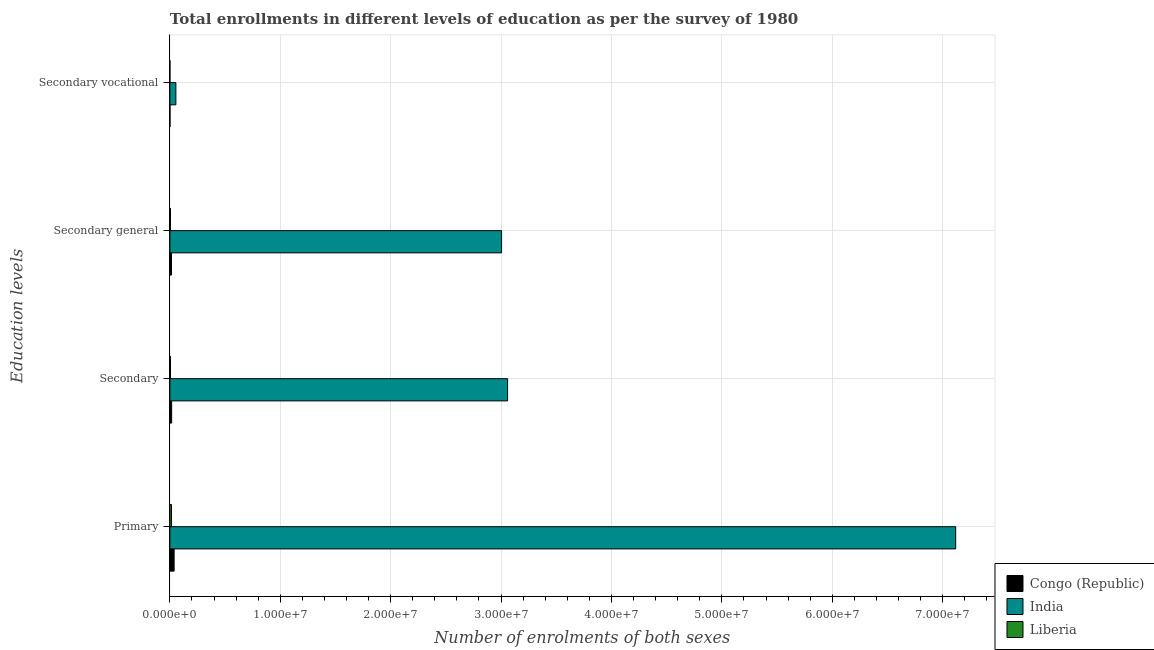How many groups of bars are there?
Your response must be concise. 4. How many bars are there on the 2nd tick from the bottom?
Keep it short and to the point. 3. What is the label of the 1st group of bars from the top?
Ensure brevity in your answer.  Secondary vocational. What is the number of enrolments in secondary general education in Congo (Republic)?
Keep it short and to the point. 1.49e+05. Across all countries, what is the maximum number of enrolments in secondary vocational education?
Provide a short and direct response. 5.44e+05. Across all countries, what is the minimum number of enrolments in primary education?
Your answer should be very brief. 1.47e+05. In which country was the number of enrolments in secondary vocational education maximum?
Your answer should be compact. India. In which country was the number of enrolments in secondary vocational education minimum?
Provide a succinct answer. Liberia. What is the total number of enrolments in secondary general education in the graph?
Offer a very short reply. 3.02e+07. What is the difference between the number of enrolments in secondary vocational education in Congo (Republic) and that in Liberia?
Provide a succinct answer. 7404. What is the difference between the number of enrolments in primary education in Congo (Republic) and the number of enrolments in secondary vocational education in Liberia?
Your response must be concise. 3.80e+05. What is the average number of enrolments in secondary education per country?
Your answer should be compact. 1.03e+07. What is the difference between the number of enrolments in secondary general education and number of enrolments in primary education in Liberia?
Your answer should be very brief. -9.56e+04. What is the ratio of the number of enrolments in secondary general education in India to that in Liberia?
Give a very brief answer. 581.59. What is the difference between the highest and the second highest number of enrolments in secondary general education?
Ensure brevity in your answer.  2.99e+07. What is the difference between the highest and the lowest number of enrolments in secondary general education?
Offer a terse response. 3.00e+07. In how many countries, is the number of enrolments in primary education greater than the average number of enrolments in primary education taken over all countries?
Ensure brevity in your answer.  1. Is it the case that in every country, the sum of the number of enrolments in secondary vocational education and number of enrolments in primary education is greater than the sum of number of enrolments in secondary general education and number of enrolments in secondary education?
Offer a very short reply. No. What does the 3rd bar from the top in Secondary represents?
Provide a short and direct response. Congo (Republic). What does the 3rd bar from the bottom in Secondary general represents?
Offer a very short reply. Liberia. Is it the case that in every country, the sum of the number of enrolments in primary education and number of enrolments in secondary education is greater than the number of enrolments in secondary general education?
Your response must be concise. Yes. How many bars are there?
Make the answer very short. 12. Are all the bars in the graph horizontal?
Provide a short and direct response. Yes. What is the difference between two consecutive major ticks on the X-axis?
Offer a terse response. 1.00e+07. What is the title of the graph?
Your answer should be very brief. Total enrollments in different levels of education as per the survey of 1980. Does "Mongolia" appear as one of the legend labels in the graph?
Your answer should be very brief. No. What is the label or title of the X-axis?
Offer a terse response. Number of enrolments of both sexes. What is the label or title of the Y-axis?
Offer a very short reply. Education levels. What is the Number of enrolments of both sexes of Congo (Republic) in Primary?
Provide a short and direct response. 3.83e+05. What is the Number of enrolments of both sexes in India in Primary?
Make the answer very short. 7.12e+07. What is the Number of enrolments of both sexes in Liberia in Primary?
Provide a succinct answer. 1.47e+05. What is the Number of enrolments of both sexes of Congo (Republic) in Secondary?
Offer a terse response. 1.59e+05. What is the Number of enrolments of both sexes in India in Secondary?
Keep it short and to the point. 3.06e+07. What is the Number of enrolments of both sexes in Liberia in Secondary?
Your answer should be very brief. 5.46e+04. What is the Number of enrolments of both sexes in Congo (Republic) in Secondary general?
Your answer should be compact. 1.49e+05. What is the Number of enrolments of both sexes in India in Secondary general?
Your answer should be very brief. 3.00e+07. What is the Number of enrolments of both sexes in Liberia in Secondary general?
Ensure brevity in your answer.  5.17e+04. What is the Number of enrolments of both sexes of Congo (Republic) in Secondary vocational?
Your answer should be compact. 1.04e+04. What is the Number of enrolments of both sexes of India in Secondary vocational?
Your answer should be very brief. 5.44e+05. What is the Number of enrolments of both sexes in Liberia in Secondary vocational?
Ensure brevity in your answer.  2957. Across all Education levels, what is the maximum Number of enrolments of both sexes in Congo (Republic)?
Your answer should be compact. 3.83e+05. Across all Education levels, what is the maximum Number of enrolments of both sexes in India?
Provide a succinct answer. 7.12e+07. Across all Education levels, what is the maximum Number of enrolments of both sexes in Liberia?
Your answer should be very brief. 1.47e+05. Across all Education levels, what is the minimum Number of enrolments of both sexes in Congo (Republic)?
Your answer should be compact. 1.04e+04. Across all Education levels, what is the minimum Number of enrolments of both sexes in India?
Your answer should be very brief. 5.44e+05. Across all Education levels, what is the minimum Number of enrolments of both sexes of Liberia?
Ensure brevity in your answer.  2957. What is the total Number of enrolments of both sexes of Congo (Republic) in the graph?
Give a very brief answer. 7.01e+05. What is the total Number of enrolments of both sexes of India in the graph?
Your answer should be compact. 1.32e+08. What is the total Number of enrolments of both sexes of Liberia in the graph?
Provide a succinct answer. 2.56e+05. What is the difference between the Number of enrolments of both sexes in Congo (Republic) in Primary and that in Secondary?
Provide a short and direct response. 2.24e+05. What is the difference between the Number of enrolments of both sexes in India in Primary and that in Secondary?
Provide a short and direct response. 4.06e+07. What is the difference between the Number of enrolments of both sexes in Liberia in Primary and that in Secondary?
Make the answer very short. 9.26e+04. What is the difference between the Number of enrolments of both sexes of Congo (Republic) in Primary and that in Secondary general?
Offer a terse response. 2.34e+05. What is the difference between the Number of enrolments of both sexes of India in Primary and that in Secondary general?
Offer a very short reply. 4.11e+07. What is the difference between the Number of enrolments of both sexes of Liberia in Primary and that in Secondary general?
Ensure brevity in your answer.  9.56e+04. What is the difference between the Number of enrolments of both sexes in Congo (Republic) in Primary and that in Secondary vocational?
Offer a terse response. 3.73e+05. What is the difference between the Number of enrolments of both sexes in India in Primary and that in Secondary vocational?
Offer a very short reply. 7.06e+07. What is the difference between the Number of enrolments of both sexes in Liberia in Primary and that in Secondary vocational?
Make the answer very short. 1.44e+05. What is the difference between the Number of enrolments of both sexes in Congo (Republic) in Secondary and that in Secondary general?
Keep it short and to the point. 1.04e+04. What is the difference between the Number of enrolments of both sexes in India in Secondary and that in Secondary general?
Ensure brevity in your answer.  5.44e+05. What is the difference between the Number of enrolments of both sexes in Liberia in Secondary and that in Secondary general?
Offer a very short reply. 2957. What is the difference between the Number of enrolments of both sexes of Congo (Republic) in Secondary and that in Secondary vocational?
Provide a short and direct response. 1.49e+05. What is the difference between the Number of enrolments of both sexes of India in Secondary and that in Secondary vocational?
Provide a succinct answer. 3.00e+07. What is the difference between the Number of enrolments of both sexes of Liberia in Secondary and that in Secondary vocational?
Your answer should be compact. 5.17e+04. What is the difference between the Number of enrolments of both sexes of Congo (Republic) in Secondary general and that in Secondary vocational?
Ensure brevity in your answer.  1.38e+05. What is the difference between the Number of enrolments of both sexes of India in Secondary general and that in Secondary vocational?
Provide a succinct answer. 2.95e+07. What is the difference between the Number of enrolments of both sexes of Liberia in Secondary general and that in Secondary vocational?
Offer a very short reply. 4.87e+04. What is the difference between the Number of enrolments of both sexes of Congo (Republic) in Primary and the Number of enrolments of both sexes of India in Secondary?
Offer a very short reply. -3.02e+07. What is the difference between the Number of enrolments of both sexes in Congo (Republic) in Primary and the Number of enrolments of both sexes in Liberia in Secondary?
Your answer should be compact. 3.28e+05. What is the difference between the Number of enrolments of both sexes in India in Primary and the Number of enrolments of both sexes in Liberia in Secondary?
Your answer should be compact. 7.11e+07. What is the difference between the Number of enrolments of both sexes of Congo (Republic) in Primary and the Number of enrolments of both sexes of India in Secondary general?
Your answer should be compact. -2.97e+07. What is the difference between the Number of enrolments of both sexes in Congo (Republic) in Primary and the Number of enrolments of both sexes in Liberia in Secondary general?
Your answer should be very brief. 3.31e+05. What is the difference between the Number of enrolments of both sexes of India in Primary and the Number of enrolments of both sexes of Liberia in Secondary general?
Give a very brief answer. 7.11e+07. What is the difference between the Number of enrolments of both sexes of Congo (Republic) in Primary and the Number of enrolments of both sexes of India in Secondary vocational?
Your answer should be compact. -1.61e+05. What is the difference between the Number of enrolments of both sexes in Congo (Republic) in Primary and the Number of enrolments of both sexes in Liberia in Secondary vocational?
Your answer should be compact. 3.80e+05. What is the difference between the Number of enrolments of both sexes of India in Primary and the Number of enrolments of both sexes of Liberia in Secondary vocational?
Give a very brief answer. 7.12e+07. What is the difference between the Number of enrolments of both sexes in Congo (Republic) in Secondary and the Number of enrolments of both sexes in India in Secondary general?
Offer a terse response. -2.99e+07. What is the difference between the Number of enrolments of both sexes in Congo (Republic) in Secondary and the Number of enrolments of both sexes in Liberia in Secondary general?
Offer a terse response. 1.08e+05. What is the difference between the Number of enrolments of both sexes in India in Secondary and the Number of enrolments of both sexes in Liberia in Secondary general?
Give a very brief answer. 3.05e+07. What is the difference between the Number of enrolments of both sexes of Congo (Republic) in Secondary and the Number of enrolments of both sexes of India in Secondary vocational?
Offer a terse response. -3.85e+05. What is the difference between the Number of enrolments of both sexes in Congo (Republic) in Secondary and the Number of enrolments of both sexes in Liberia in Secondary vocational?
Make the answer very short. 1.56e+05. What is the difference between the Number of enrolments of both sexes in India in Secondary and the Number of enrolments of both sexes in Liberia in Secondary vocational?
Offer a very short reply. 3.06e+07. What is the difference between the Number of enrolments of both sexes of Congo (Republic) in Secondary general and the Number of enrolments of both sexes of India in Secondary vocational?
Your response must be concise. -3.95e+05. What is the difference between the Number of enrolments of both sexes of Congo (Republic) in Secondary general and the Number of enrolments of both sexes of Liberia in Secondary vocational?
Your response must be concise. 1.46e+05. What is the difference between the Number of enrolments of both sexes of India in Secondary general and the Number of enrolments of both sexes of Liberia in Secondary vocational?
Keep it short and to the point. 3.00e+07. What is the average Number of enrolments of both sexes of Congo (Republic) per Education levels?
Keep it short and to the point. 1.75e+05. What is the average Number of enrolments of both sexes in India per Education levels?
Offer a very short reply. 3.31e+07. What is the average Number of enrolments of both sexes in Liberia per Education levels?
Your answer should be very brief. 6.41e+04. What is the difference between the Number of enrolments of both sexes of Congo (Republic) and Number of enrolments of both sexes of India in Primary?
Provide a succinct answer. -7.08e+07. What is the difference between the Number of enrolments of both sexes of Congo (Republic) and Number of enrolments of both sexes of Liberia in Primary?
Your answer should be compact. 2.36e+05. What is the difference between the Number of enrolments of both sexes in India and Number of enrolments of both sexes in Liberia in Primary?
Your answer should be compact. 7.10e+07. What is the difference between the Number of enrolments of both sexes in Congo (Republic) and Number of enrolments of both sexes in India in Secondary?
Give a very brief answer. -3.04e+07. What is the difference between the Number of enrolments of both sexes of Congo (Republic) and Number of enrolments of both sexes of Liberia in Secondary?
Provide a succinct answer. 1.05e+05. What is the difference between the Number of enrolments of both sexes in India and Number of enrolments of both sexes in Liberia in Secondary?
Keep it short and to the point. 3.05e+07. What is the difference between the Number of enrolments of both sexes of Congo (Republic) and Number of enrolments of both sexes of India in Secondary general?
Ensure brevity in your answer.  -2.99e+07. What is the difference between the Number of enrolments of both sexes in Congo (Republic) and Number of enrolments of both sexes in Liberia in Secondary general?
Give a very brief answer. 9.72e+04. What is the difference between the Number of enrolments of both sexes of India and Number of enrolments of both sexes of Liberia in Secondary general?
Offer a very short reply. 3.00e+07. What is the difference between the Number of enrolments of both sexes in Congo (Republic) and Number of enrolments of both sexes in India in Secondary vocational?
Offer a terse response. -5.34e+05. What is the difference between the Number of enrolments of both sexes of Congo (Republic) and Number of enrolments of both sexes of Liberia in Secondary vocational?
Keep it short and to the point. 7404. What is the difference between the Number of enrolments of both sexes in India and Number of enrolments of both sexes in Liberia in Secondary vocational?
Your answer should be compact. 5.41e+05. What is the ratio of the Number of enrolments of both sexes in Congo (Republic) in Primary to that in Secondary?
Make the answer very short. 2.41. What is the ratio of the Number of enrolments of both sexes in India in Primary to that in Secondary?
Make the answer very short. 2.33. What is the ratio of the Number of enrolments of both sexes in Liberia in Primary to that in Secondary?
Keep it short and to the point. 2.7. What is the ratio of the Number of enrolments of both sexes in Congo (Republic) in Primary to that in Secondary general?
Your answer should be very brief. 2.57. What is the ratio of the Number of enrolments of both sexes in India in Primary to that in Secondary general?
Your answer should be very brief. 2.37. What is the ratio of the Number of enrolments of both sexes of Liberia in Primary to that in Secondary general?
Your answer should be very brief. 2.85. What is the ratio of the Number of enrolments of both sexes in Congo (Republic) in Primary to that in Secondary vocational?
Your answer should be very brief. 36.97. What is the ratio of the Number of enrolments of both sexes of India in Primary to that in Secondary vocational?
Offer a terse response. 130.86. What is the ratio of the Number of enrolments of both sexes in Liberia in Primary to that in Secondary vocational?
Your response must be concise. 49.79. What is the ratio of the Number of enrolments of both sexes in Congo (Republic) in Secondary to that in Secondary general?
Your answer should be compact. 1.07. What is the ratio of the Number of enrolments of both sexes of India in Secondary to that in Secondary general?
Give a very brief answer. 1.02. What is the ratio of the Number of enrolments of both sexes in Liberia in Secondary to that in Secondary general?
Your response must be concise. 1.06. What is the ratio of the Number of enrolments of both sexes in Congo (Republic) in Secondary to that in Secondary vocational?
Keep it short and to the point. 15.37. What is the ratio of the Number of enrolments of both sexes of India in Secondary to that in Secondary vocational?
Your answer should be compact. 56.24. What is the ratio of the Number of enrolments of both sexes of Liberia in Secondary to that in Secondary vocational?
Provide a succinct answer. 18.47. What is the ratio of the Number of enrolments of both sexes of Congo (Republic) in Secondary general to that in Secondary vocational?
Keep it short and to the point. 14.37. What is the ratio of the Number of enrolments of both sexes in India in Secondary general to that in Secondary vocational?
Ensure brevity in your answer.  55.24. What is the ratio of the Number of enrolments of both sexes of Liberia in Secondary general to that in Secondary vocational?
Provide a short and direct response. 17.47. What is the difference between the highest and the second highest Number of enrolments of both sexes of Congo (Republic)?
Your response must be concise. 2.24e+05. What is the difference between the highest and the second highest Number of enrolments of both sexes of India?
Ensure brevity in your answer.  4.06e+07. What is the difference between the highest and the second highest Number of enrolments of both sexes of Liberia?
Make the answer very short. 9.26e+04. What is the difference between the highest and the lowest Number of enrolments of both sexes of Congo (Republic)?
Your answer should be compact. 3.73e+05. What is the difference between the highest and the lowest Number of enrolments of both sexes in India?
Ensure brevity in your answer.  7.06e+07. What is the difference between the highest and the lowest Number of enrolments of both sexes of Liberia?
Your answer should be very brief. 1.44e+05. 